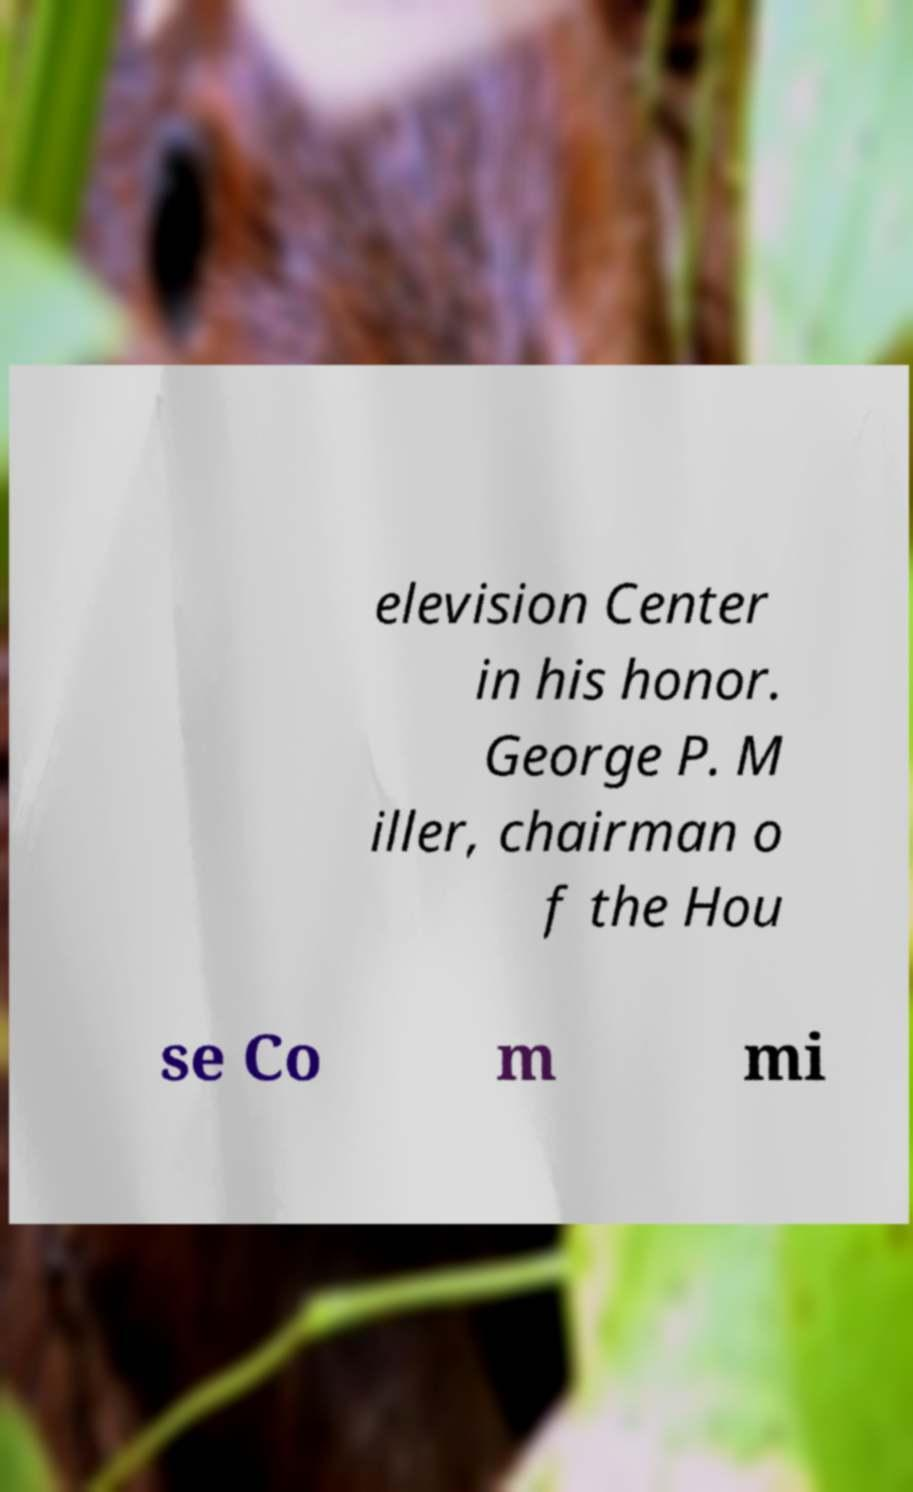Can you read and provide the text displayed in the image?This photo seems to have some interesting text. Can you extract and type it out for me? elevision Center in his honor. George P. M iller, chairman o f the Hou se Co m mi 